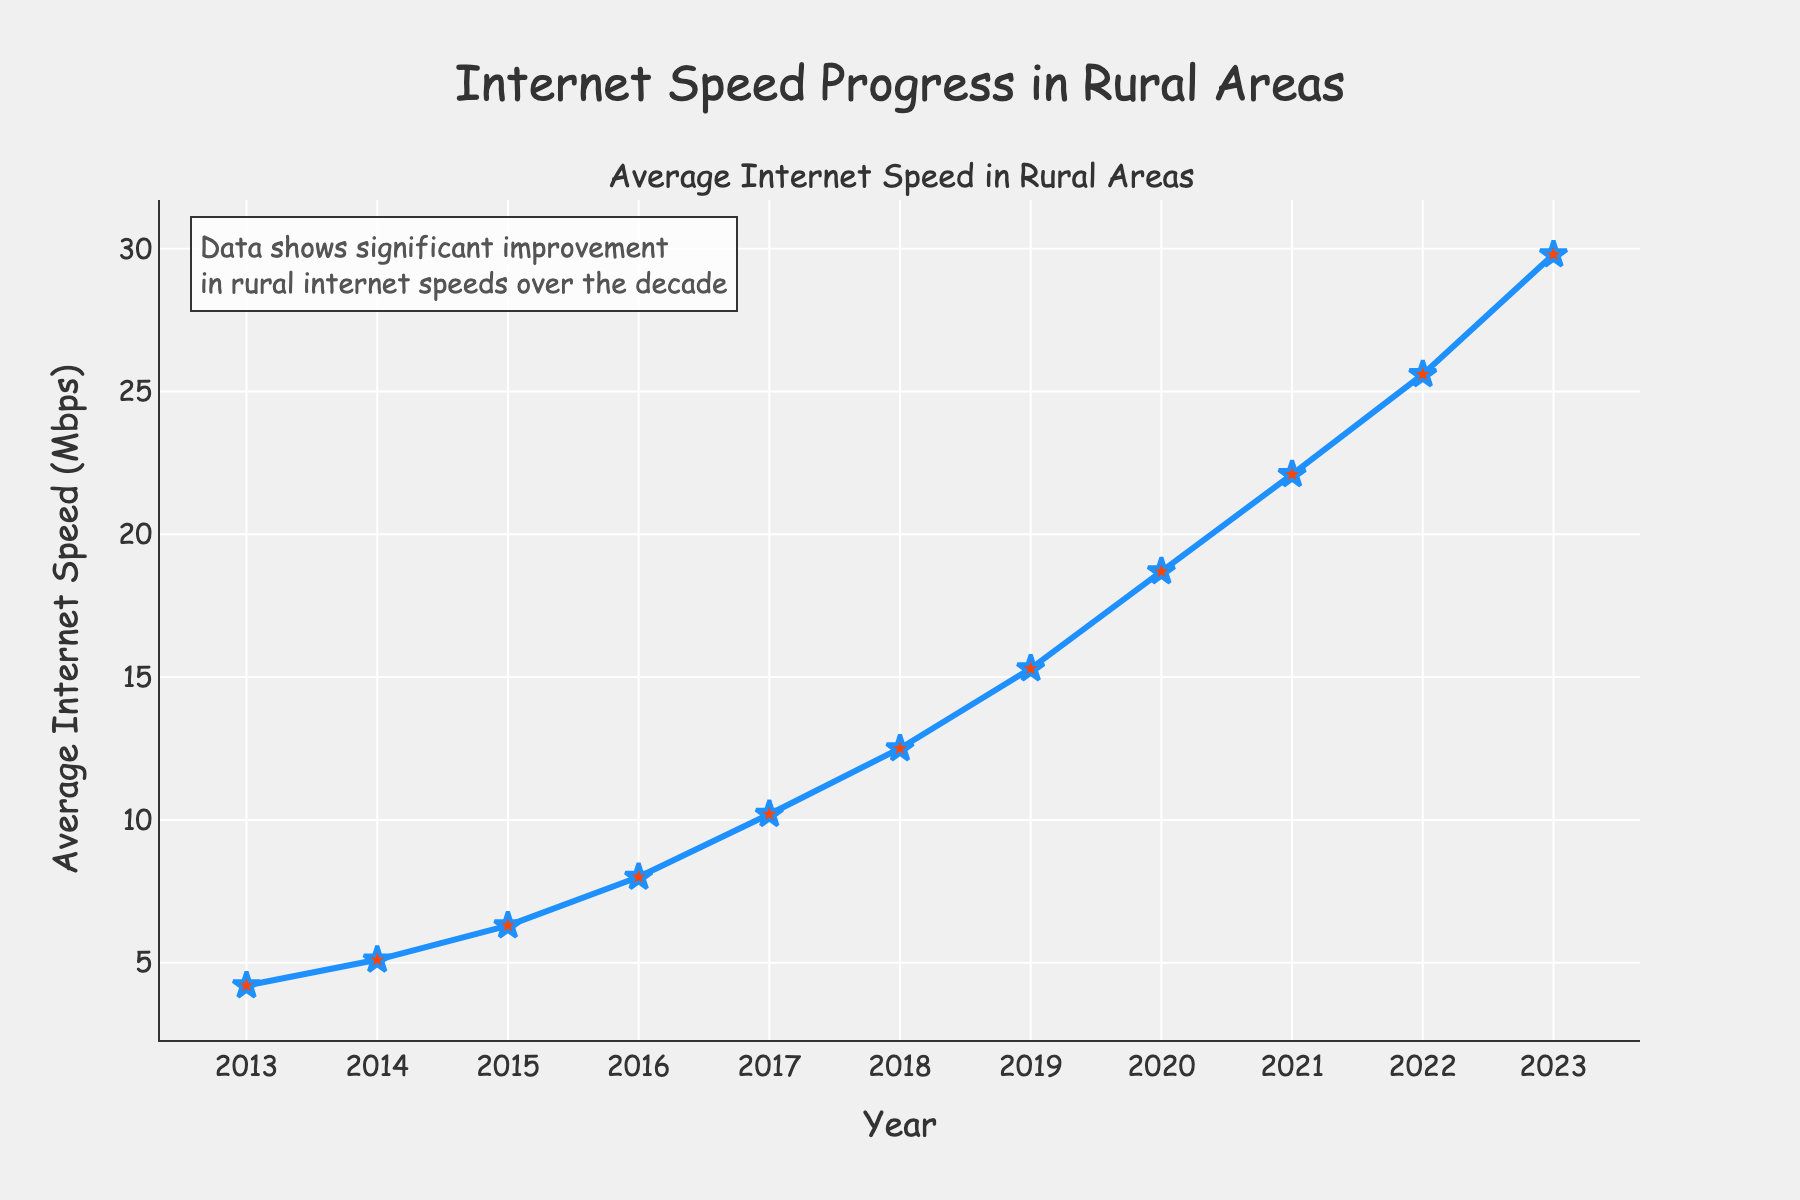What is the average internet speed in 2018? Look at the data point corresponding to the year 2018 on the x-axis and find the y-axis value for that year, which is the internet speed.
Answer: 12.5 Mbps Which year shows the largest increase in internet speed compared to the previous year? Compare the increase in internet speed for each consecutive year. The difference between 2023 and 2022 is the largest: 29.8 - 25.6 = 4.2 Mbps.
Answer: 2023 How much did the internet speed increase from 2013 to 2018? Subtract the internet speed in 2013 from the speed in 2018: 12.5 - 4.2 = 8.3 Mbps.
Answer: 8.3 Mbps How does the internet speed in 2020 compare to the speed in 2015? Find the internet speeds for 2020 and 2015, then compare them. The speed in 2020 is 18.7 Mbps, which is higher than 6.3 Mbps in 2015.
Answer: Higher What is the median internet speed from 2013 to 2023? The median is calculated by ordering the speeds and finding the middle value. Ordered speeds: 4.2, 5.1, 6.3, 8.0, 10.2, 12.5, 15.3, 18.7, 22.1, 25.6, 29.8. The median value (middle value) is 12.5 Mbps.
Answer: 12.5 Mbps During which years did the internet speed double compared to the starting year (2013)? Internet speed in 2013 is 4.2 Mbps. Double this value is 8.4 Mbps. Find the first year where speed is ≥ 8.4. The first year is 2017 with 10.2 Mbps.
Answer: 2017 From which year did the internet speed consistently stay above 10 Mbps? Check the figure to identify the year when speeds first exceed 10 Mbps and remain above this threshold. This is from 2017 onwards.
Answer: 2017 What is the average internet speed for the years 2021 to 2023? Average is calculated by adding the speeds for 2021, 2022 and 2023, and then divided by 3: (22.1 + 25.6 + 29.8) / 3 = 25.83 Mbps.
Answer: 25.83 Mbps Compare the internet speed increments between 2013-2018 and 2018-2023. Which period has a higher total increment? Calculate the total increment in each period: For 2013-2018, (12.5-4.2) = 8.3 Mbps; for 2018-2023, (29.8-12.5) = 17.3 Mbps. The latter period has a higher increment.
Answer: 2018-2023 What trend do you observe in the internet speed from 2013 to 2023? Observe the plot's overall direction, which shows a consistent upward trend in internet speed.
Answer: Increasing 